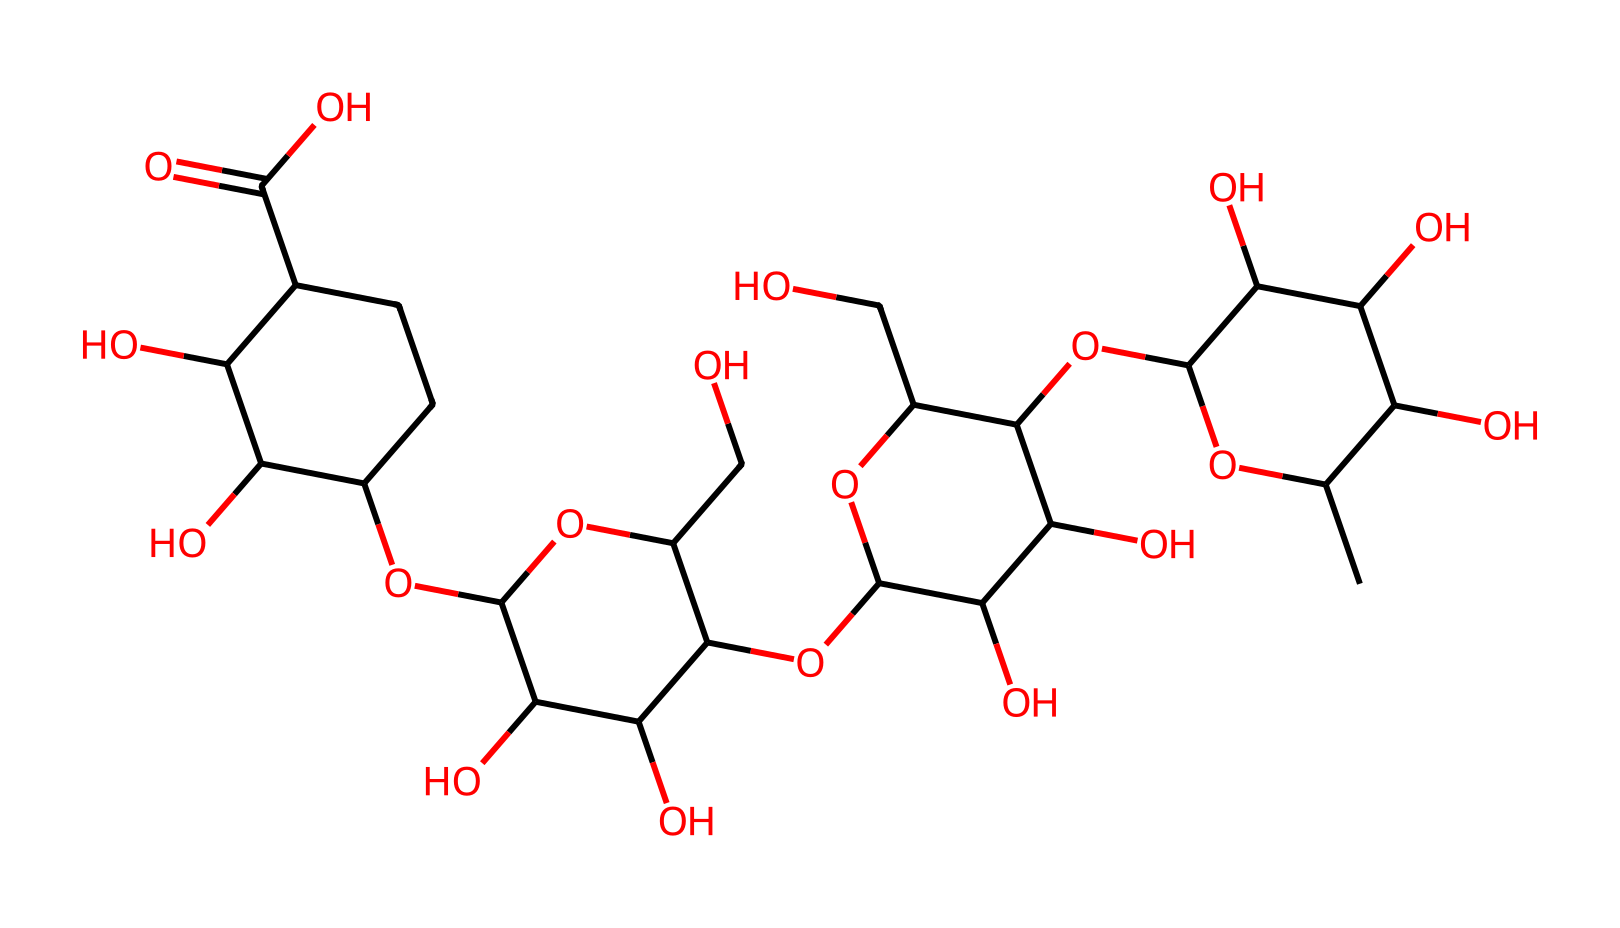What is the main structural feature of xanthan gum that contributes to its viscosity? Xanthan gum contains a complex, branched polysaccharide structure with multiple hydroxyl (-OH) groups that can interact with water, forming a gel-like substance that increases viscosity.
Answer: polysaccharide How many carbon atoms are present in the xanthan gum's chemical structure? By analyzing the SMILES representation, one can count the number of carbon (C) atoms; there are 30 carbon atoms in the structure.
Answer: 30 What functional groups are predominantly found in the xanthan gum structure? The chemical structure shows multiple hydroxyl (-OH) groups and a carboxylic acid (-COOH) group, which are the primary functional groups present.
Answer: hydroxyl and carboxylic acid What effect does xanthan gum have when mixed with water? Xanthan gum forms a gel-like solution with water due to its non-Newtonian fluid properties, which allows it to behave differently under stress, emphasizing its thickening ability.
Answer: gel-like solution What type of fluid is xanthan gum considered when used in topical gels? Xanthan gum is classified as a non-Newtonian fluid because its viscosity changes with the amount of stress applied, making it suitable for applications in topical pain relief gels.
Answer: non-Newtonian fluid How does xanthan gum's structure support its use in sports injury treatments? The branched and modular nature of xanthan gum allows for effective binding of water, which promotes moisture retention and enhances penetration of active ingredients in topical formulations designed for pain relief.
Answer: moisture retention 